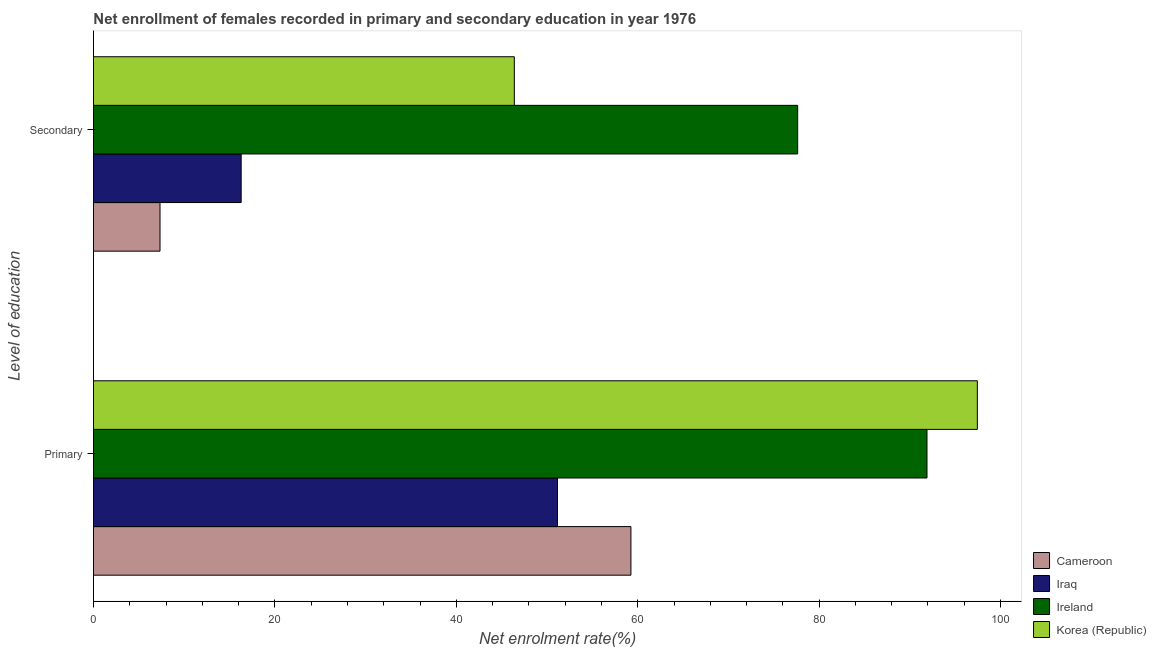Are the number of bars on each tick of the Y-axis equal?
Keep it short and to the point. Yes. How many bars are there on the 1st tick from the top?
Make the answer very short. 4. What is the label of the 2nd group of bars from the top?
Provide a succinct answer. Primary. What is the enrollment rate in primary education in Korea (Republic)?
Keep it short and to the point. 97.44. Across all countries, what is the maximum enrollment rate in primary education?
Your answer should be very brief. 97.44. Across all countries, what is the minimum enrollment rate in primary education?
Provide a succinct answer. 51.16. In which country was the enrollment rate in secondary education maximum?
Your answer should be very brief. Ireland. In which country was the enrollment rate in primary education minimum?
Provide a short and direct response. Iraq. What is the total enrollment rate in secondary education in the graph?
Offer a terse response. 147.65. What is the difference between the enrollment rate in secondary education in Iraq and that in Cameroon?
Give a very brief answer. 8.95. What is the difference between the enrollment rate in secondary education in Cameroon and the enrollment rate in primary education in Korea (Republic)?
Offer a terse response. -90.11. What is the average enrollment rate in secondary education per country?
Give a very brief answer. 36.91. What is the difference between the enrollment rate in secondary education and enrollment rate in primary education in Ireland?
Your response must be concise. -14.26. In how many countries, is the enrollment rate in primary education greater than 40 %?
Make the answer very short. 4. What is the ratio of the enrollment rate in primary education in Korea (Republic) to that in Iraq?
Give a very brief answer. 1.9. What does the 2nd bar from the bottom in Primary represents?
Your answer should be compact. Iraq. How many bars are there?
Provide a succinct answer. 8. Are the values on the major ticks of X-axis written in scientific E-notation?
Give a very brief answer. No. Does the graph contain any zero values?
Ensure brevity in your answer.  No. Where does the legend appear in the graph?
Provide a short and direct response. Bottom right. What is the title of the graph?
Ensure brevity in your answer.  Net enrollment of females recorded in primary and secondary education in year 1976. What is the label or title of the X-axis?
Give a very brief answer. Net enrolment rate(%). What is the label or title of the Y-axis?
Your response must be concise. Level of education. What is the Net enrolment rate(%) in Cameroon in Primary?
Provide a succinct answer. 59.25. What is the Net enrolment rate(%) of Iraq in Primary?
Your answer should be compact. 51.16. What is the Net enrolment rate(%) in Ireland in Primary?
Offer a terse response. 91.89. What is the Net enrolment rate(%) in Korea (Republic) in Primary?
Offer a very short reply. 97.44. What is the Net enrolment rate(%) of Cameroon in Secondary?
Offer a very short reply. 7.34. What is the Net enrolment rate(%) of Iraq in Secondary?
Keep it short and to the point. 16.28. What is the Net enrolment rate(%) of Ireland in Secondary?
Provide a succinct answer. 77.63. What is the Net enrolment rate(%) of Korea (Republic) in Secondary?
Give a very brief answer. 46.4. Across all Level of education, what is the maximum Net enrolment rate(%) in Cameroon?
Your answer should be very brief. 59.25. Across all Level of education, what is the maximum Net enrolment rate(%) in Iraq?
Ensure brevity in your answer.  51.16. Across all Level of education, what is the maximum Net enrolment rate(%) of Ireland?
Ensure brevity in your answer.  91.89. Across all Level of education, what is the maximum Net enrolment rate(%) of Korea (Republic)?
Provide a short and direct response. 97.44. Across all Level of education, what is the minimum Net enrolment rate(%) in Cameroon?
Your answer should be compact. 7.34. Across all Level of education, what is the minimum Net enrolment rate(%) of Iraq?
Provide a short and direct response. 16.28. Across all Level of education, what is the minimum Net enrolment rate(%) in Ireland?
Make the answer very short. 77.63. Across all Level of education, what is the minimum Net enrolment rate(%) in Korea (Republic)?
Keep it short and to the point. 46.4. What is the total Net enrolment rate(%) in Cameroon in the graph?
Ensure brevity in your answer.  66.59. What is the total Net enrolment rate(%) of Iraq in the graph?
Your response must be concise. 67.44. What is the total Net enrolment rate(%) of Ireland in the graph?
Offer a very short reply. 169.53. What is the total Net enrolment rate(%) of Korea (Republic) in the graph?
Provide a succinct answer. 143.84. What is the difference between the Net enrolment rate(%) in Cameroon in Primary and that in Secondary?
Provide a short and direct response. 51.91. What is the difference between the Net enrolment rate(%) of Iraq in Primary and that in Secondary?
Ensure brevity in your answer.  34.87. What is the difference between the Net enrolment rate(%) in Ireland in Primary and that in Secondary?
Offer a very short reply. 14.26. What is the difference between the Net enrolment rate(%) of Korea (Republic) in Primary and that in Secondary?
Give a very brief answer. 51.05. What is the difference between the Net enrolment rate(%) in Cameroon in Primary and the Net enrolment rate(%) in Iraq in Secondary?
Offer a very short reply. 42.97. What is the difference between the Net enrolment rate(%) of Cameroon in Primary and the Net enrolment rate(%) of Ireland in Secondary?
Your response must be concise. -18.38. What is the difference between the Net enrolment rate(%) in Cameroon in Primary and the Net enrolment rate(%) in Korea (Republic) in Secondary?
Provide a short and direct response. 12.86. What is the difference between the Net enrolment rate(%) in Iraq in Primary and the Net enrolment rate(%) in Ireland in Secondary?
Your response must be concise. -26.48. What is the difference between the Net enrolment rate(%) in Iraq in Primary and the Net enrolment rate(%) in Korea (Republic) in Secondary?
Make the answer very short. 4.76. What is the difference between the Net enrolment rate(%) of Ireland in Primary and the Net enrolment rate(%) of Korea (Republic) in Secondary?
Your answer should be very brief. 45.49. What is the average Net enrolment rate(%) in Cameroon per Level of education?
Provide a short and direct response. 33.29. What is the average Net enrolment rate(%) of Iraq per Level of education?
Provide a short and direct response. 33.72. What is the average Net enrolment rate(%) in Ireland per Level of education?
Offer a terse response. 84.76. What is the average Net enrolment rate(%) of Korea (Republic) per Level of education?
Provide a short and direct response. 71.92. What is the difference between the Net enrolment rate(%) of Cameroon and Net enrolment rate(%) of Iraq in Primary?
Give a very brief answer. 8.1. What is the difference between the Net enrolment rate(%) of Cameroon and Net enrolment rate(%) of Ireland in Primary?
Your response must be concise. -32.64. What is the difference between the Net enrolment rate(%) in Cameroon and Net enrolment rate(%) in Korea (Republic) in Primary?
Ensure brevity in your answer.  -38.19. What is the difference between the Net enrolment rate(%) of Iraq and Net enrolment rate(%) of Ireland in Primary?
Ensure brevity in your answer.  -40.73. What is the difference between the Net enrolment rate(%) in Iraq and Net enrolment rate(%) in Korea (Republic) in Primary?
Offer a very short reply. -46.29. What is the difference between the Net enrolment rate(%) in Ireland and Net enrolment rate(%) in Korea (Republic) in Primary?
Your answer should be compact. -5.55. What is the difference between the Net enrolment rate(%) in Cameroon and Net enrolment rate(%) in Iraq in Secondary?
Provide a succinct answer. -8.95. What is the difference between the Net enrolment rate(%) in Cameroon and Net enrolment rate(%) in Ireland in Secondary?
Keep it short and to the point. -70.3. What is the difference between the Net enrolment rate(%) of Cameroon and Net enrolment rate(%) of Korea (Republic) in Secondary?
Ensure brevity in your answer.  -39.06. What is the difference between the Net enrolment rate(%) of Iraq and Net enrolment rate(%) of Ireland in Secondary?
Your answer should be compact. -61.35. What is the difference between the Net enrolment rate(%) in Iraq and Net enrolment rate(%) in Korea (Republic) in Secondary?
Offer a very short reply. -30.11. What is the difference between the Net enrolment rate(%) of Ireland and Net enrolment rate(%) of Korea (Republic) in Secondary?
Make the answer very short. 31.24. What is the ratio of the Net enrolment rate(%) of Cameroon in Primary to that in Secondary?
Offer a very short reply. 8.08. What is the ratio of the Net enrolment rate(%) in Iraq in Primary to that in Secondary?
Your answer should be very brief. 3.14. What is the ratio of the Net enrolment rate(%) of Ireland in Primary to that in Secondary?
Provide a short and direct response. 1.18. What is the ratio of the Net enrolment rate(%) in Korea (Republic) in Primary to that in Secondary?
Keep it short and to the point. 2.1. What is the difference between the highest and the second highest Net enrolment rate(%) of Cameroon?
Keep it short and to the point. 51.91. What is the difference between the highest and the second highest Net enrolment rate(%) in Iraq?
Offer a very short reply. 34.87. What is the difference between the highest and the second highest Net enrolment rate(%) of Ireland?
Keep it short and to the point. 14.26. What is the difference between the highest and the second highest Net enrolment rate(%) of Korea (Republic)?
Keep it short and to the point. 51.05. What is the difference between the highest and the lowest Net enrolment rate(%) in Cameroon?
Offer a terse response. 51.91. What is the difference between the highest and the lowest Net enrolment rate(%) of Iraq?
Give a very brief answer. 34.87. What is the difference between the highest and the lowest Net enrolment rate(%) in Ireland?
Your answer should be very brief. 14.26. What is the difference between the highest and the lowest Net enrolment rate(%) in Korea (Republic)?
Offer a very short reply. 51.05. 